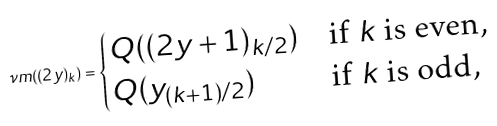Convert formula to latex. <formula><loc_0><loc_0><loc_500><loc_500>\nu m ( ( 2 y ) _ { k } ) = \begin{cases} Q ( ( 2 y + 1 ) _ { k / 2 } ) & \text {if $k$ is even,} \\ Q ( y _ { ( k + 1 ) / 2 } ) & \text {if $k$ is odd,} \end{cases}</formula> 